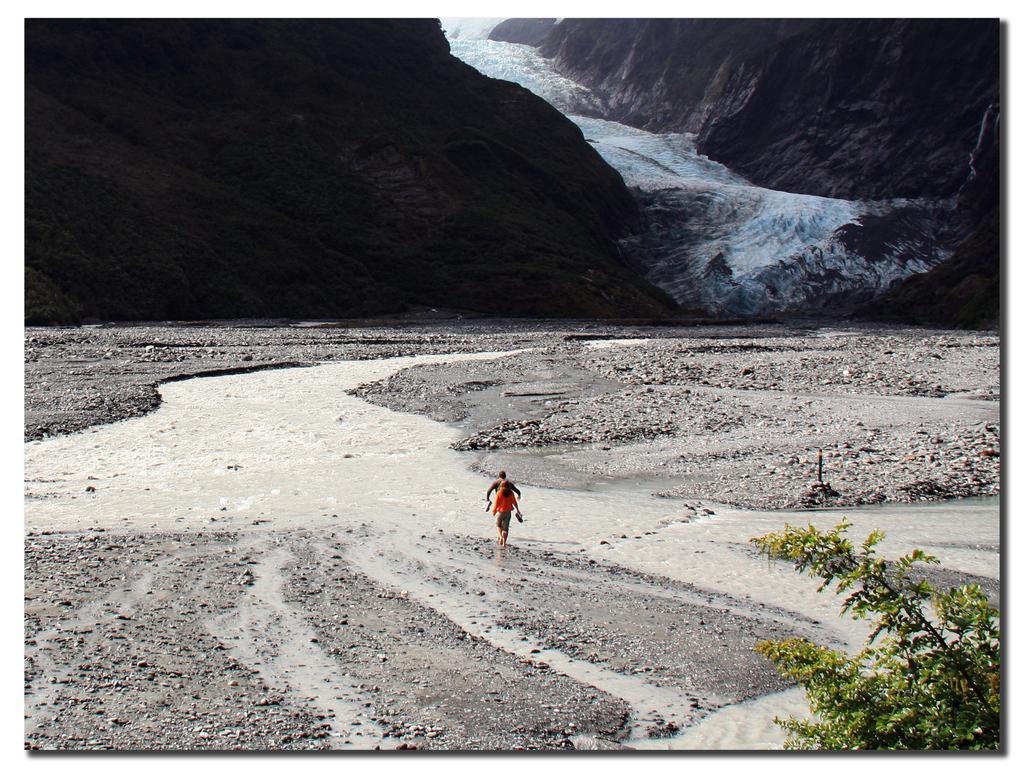Please provide a concise description of this image. In this picture there is a man and a woman in the center of the image, there is water in the center and at the top side of the image, there is a tree in the bottom right side of the image and there are mountains at the top side of the image. 